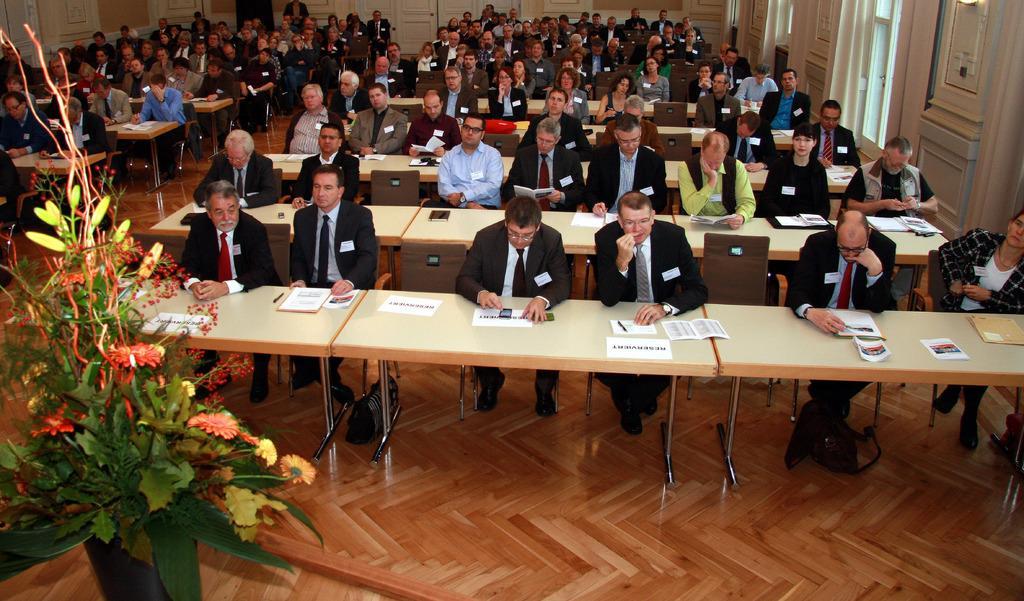Can you describe this image briefly? Here we can see some persons are sitting on the chairs. These are the tables. On the table there are papers. This is floor and there is a flower vase. And this is door. 